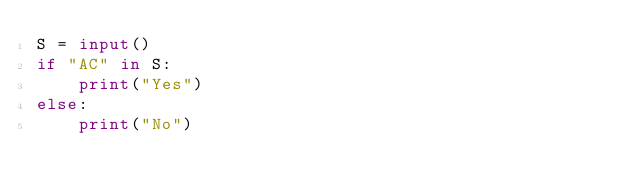<code> <loc_0><loc_0><loc_500><loc_500><_Python_>S = input()
if "AC" in S:
    print("Yes")
else:
    print("No")</code> 